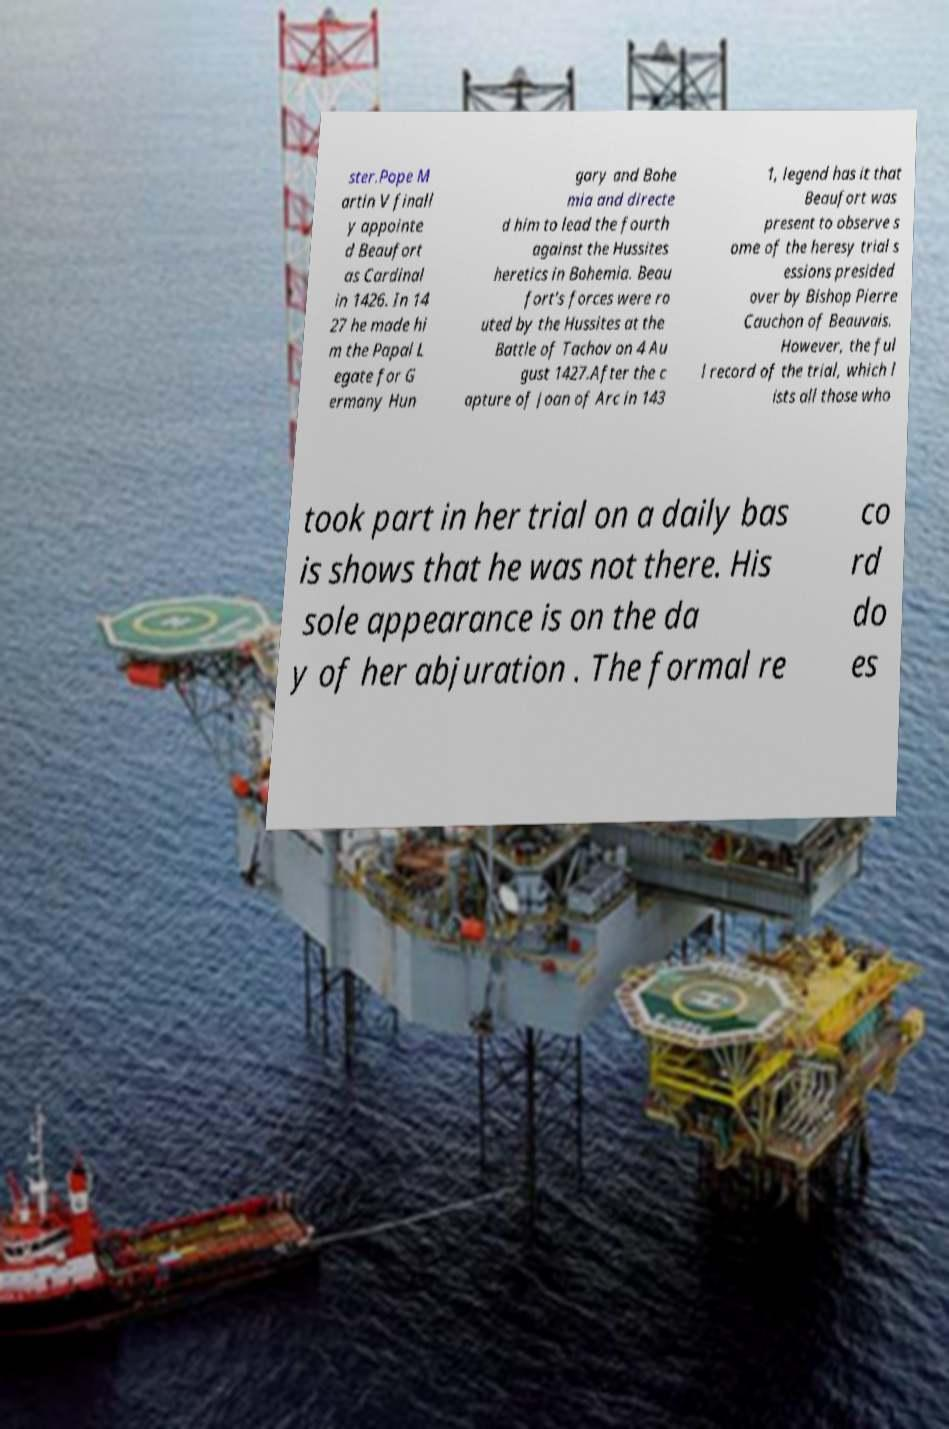There's text embedded in this image that I need extracted. Can you transcribe it verbatim? ster.Pope M artin V finall y appointe d Beaufort as Cardinal in 1426. In 14 27 he made hi m the Papal L egate for G ermany Hun gary and Bohe mia and directe d him to lead the fourth against the Hussites heretics in Bohemia. Beau fort's forces were ro uted by the Hussites at the Battle of Tachov on 4 Au gust 1427.After the c apture of Joan of Arc in 143 1, legend has it that Beaufort was present to observe s ome of the heresy trial s essions presided over by Bishop Pierre Cauchon of Beauvais. However, the ful l record of the trial, which l ists all those who took part in her trial on a daily bas is shows that he was not there. His sole appearance is on the da y of her abjuration . The formal re co rd do es 